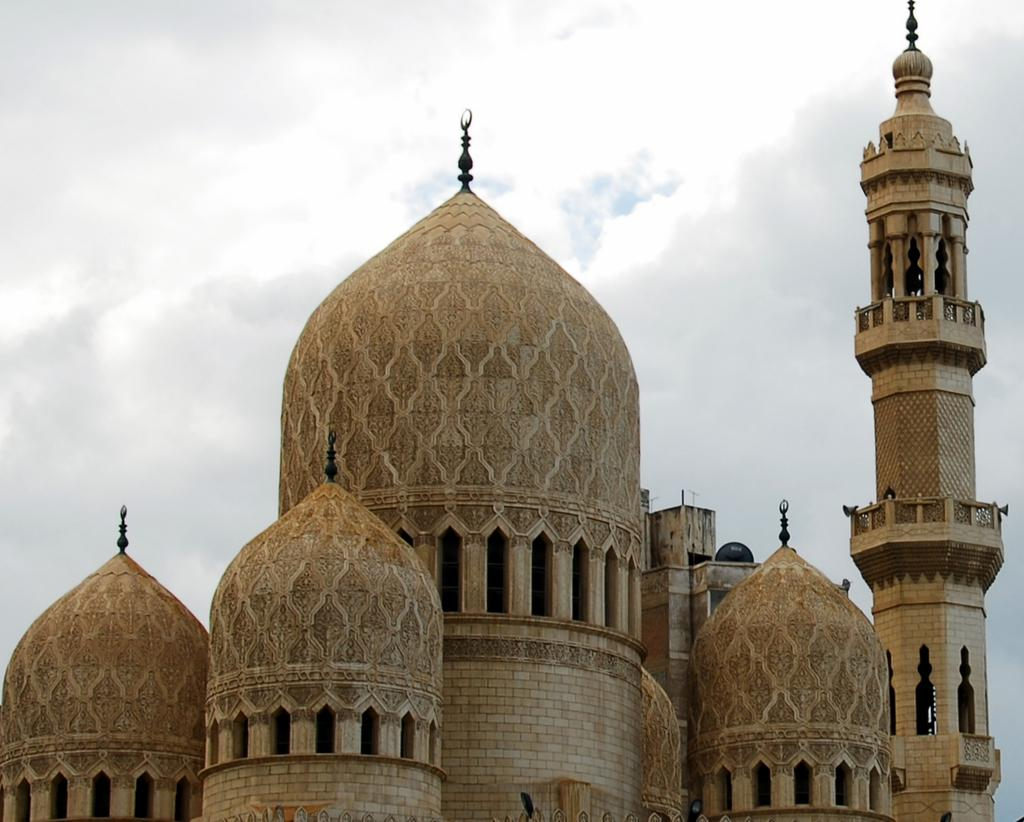What is the main subject in the foreground of the image? There is a mosque in the foreground of the image. What can be seen in the background of the image? The sky is visible in the background of the image. What is the condition of the sky in the image? There are clouds in the sky. What type of cracker is being used to build a snowman in the image? There is no cracker or snowman present in the image; it features a mosque and clouds in the sky. Is there any indication of winter weather in the image? The image does not provide any information about the weather or season, as it only shows a mosque and clouds in the sky. 